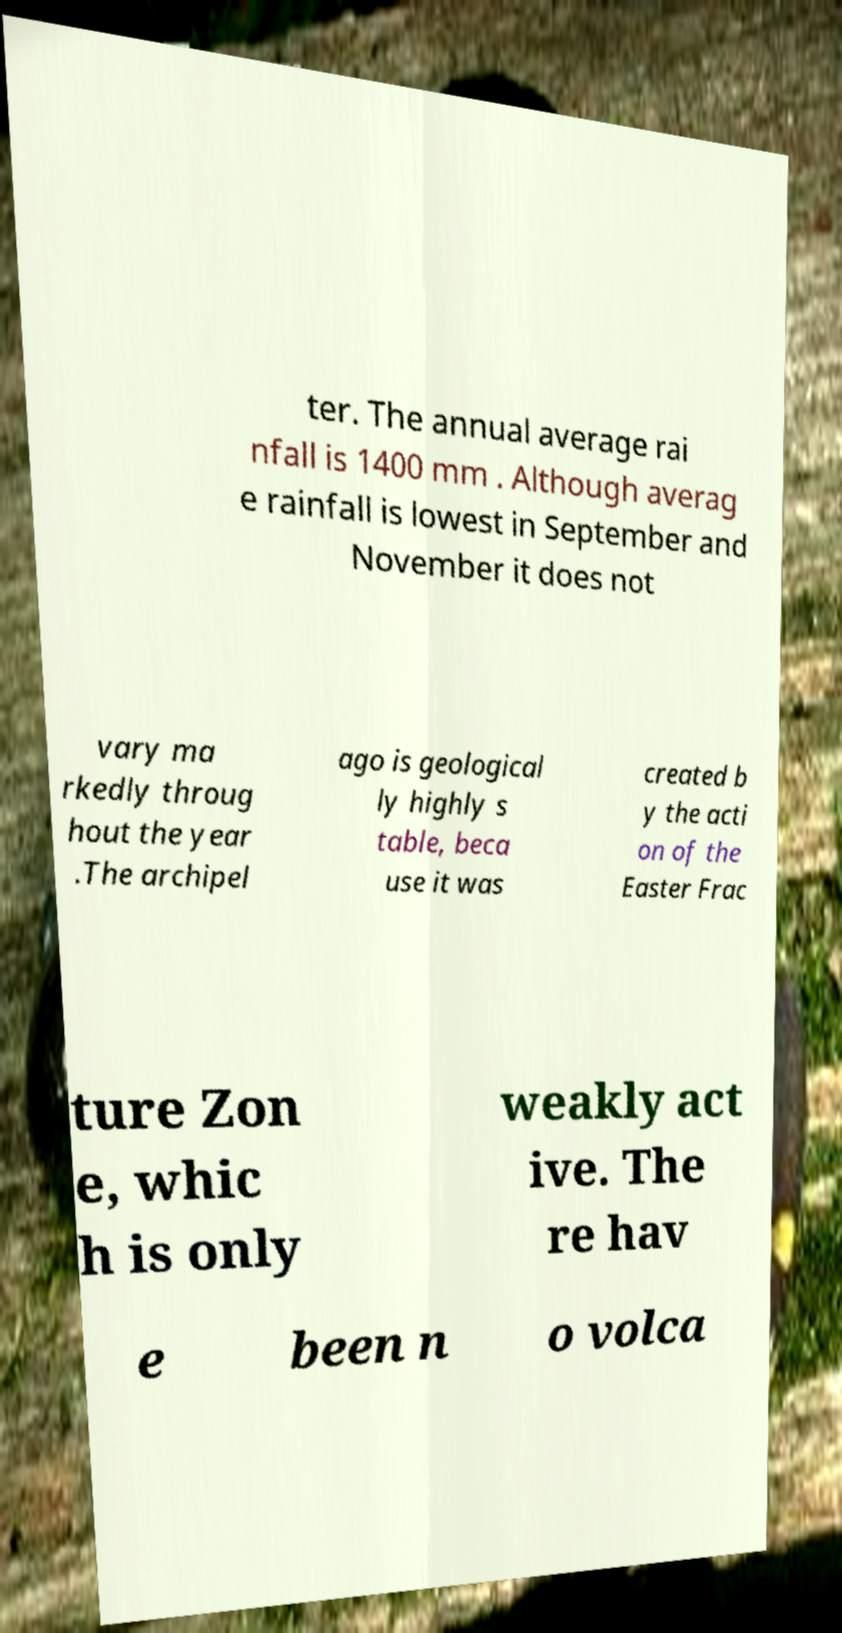There's text embedded in this image that I need extracted. Can you transcribe it verbatim? ter. The annual average rai nfall is 1400 mm . Although averag e rainfall is lowest in September and November it does not vary ma rkedly throug hout the year .The archipel ago is geological ly highly s table, beca use it was created b y the acti on of the Easter Frac ture Zon e, whic h is only weakly act ive. The re hav e been n o volca 